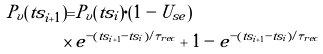<formula> <loc_0><loc_0><loc_500><loc_500>P _ { v } ( t s _ { i + 1 } ) = & P _ { v } ( t s _ { i } ) \cdot ( 1 - U _ { s e } ) \\ \times \, & e ^ { - ( t s _ { i + 1 } - t s _ { i } ) / \tau _ { r e c } } + 1 - e ^ { - ( t s _ { i + 1 } - t s _ { i } ) / \tau _ { r e c } }</formula> 